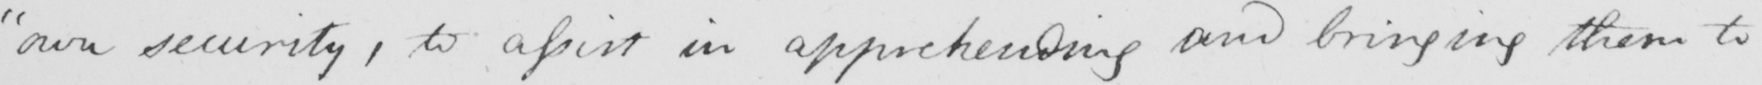What is written in this line of handwriting? "own security, to assist in apprehending and bringing them to 